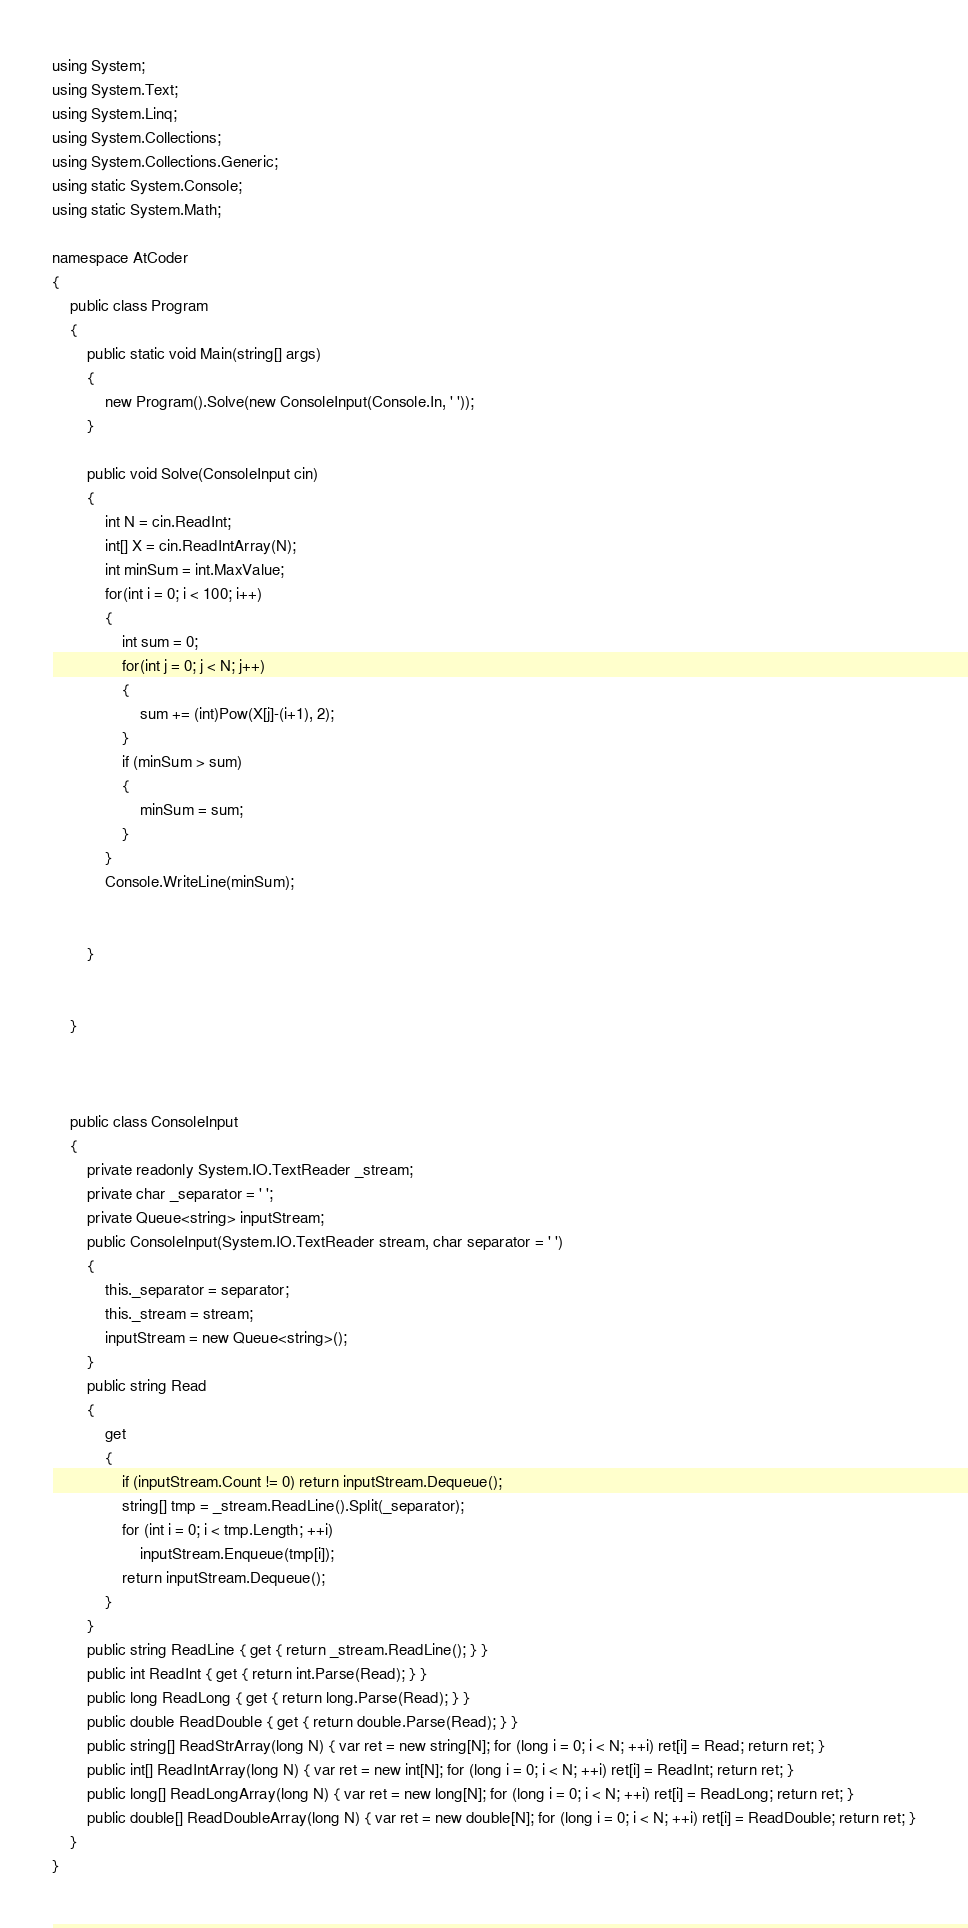Convert code to text. <code><loc_0><loc_0><loc_500><loc_500><_C#_>using System;
using System.Text;
using System.Linq;
using System.Collections;
using System.Collections.Generic;
using static System.Console;
using static System.Math;

namespace AtCoder
{
    public class Program
    {
        public static void Main(string[] args)
        {
            new Program().Solve(new ConsoleInput(Console.In, ' '));
        }

        public void Solve(ConsoleInput cin)
        {
            int N = cin.ReadInt;
            int[] X = cin.ReadIntArray(N);
            int minSum = int.MaxValue;
            for(int i = 0; i < 100; i++)
            {
                int sum = 0;
                for(int j = 0; j < N; j++)
                {
                    sum += (int)Pow(X[j]-(i+1), 2);
                }
                if (minSum > sum)
                {
                    minSum = sum;
                }
            }
            Console.WriteLine(minSum);
            
            
        }


    }
            


    public class ConsoleInput
    {
        private readonly System.IO.TextReader _stream;
        private char _separator = ' ';
        private Queue<string> inputStream;
        public ConsoleInput(System.IO.TextReader stream, char separator = ' ')
        {
            this._separator = separator;
            this._stream = stream;
            inputStream = new Queue<string>();
        }
        public string Read
        {
            get
            {
                if (inputStream.Count != 0) return inputStream.Dequeue();
                string[] tmp = _stream.ReadLine().Split(_separator);
                for (int i = 0; i < tmp.Length; ++i)
                    inputStream.Enqueue(tmp[i]);
                return inputStream.Dequeue();
            }
        }
        public string ReadLine { get { return _stream.ReadLine(); } }
        public int ReadInt { get { return int.Parse(Read); } }
        public long ReadLong { get { return long.Parse(Read); } }
        public double ReadDouble { get { return double.Parse(Read); } }
        public string[] ReadStrArray(long N) { var ret = new string[N]; for (long i = 0; i < N; ++i) ret[i] = Read; return ret; }
        public int[] ReadIntArray(long N) { var ret = new int[N]; for (long i = 0; i < N; ++i) ret[i] = ReadInt; return ret; }
        public long[] ReadLongArray(long N) { var ret = new long[N]; for (long i = 0; i < N; ++i) ret[i] = ReadLong; return ret; }
        public double[] ReadDoubleArray(long N) { var ret = new double[N]; for (long i = 0; i < N; ++i) ret[i] = ReadDouble; return ret; }
    }
}
</code> 